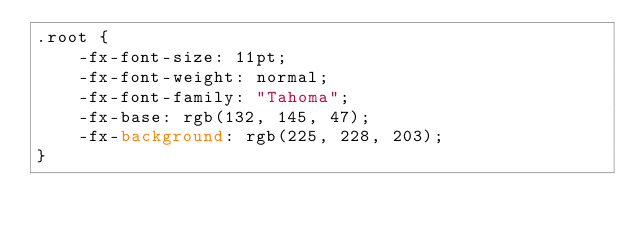Convert code to text. <code><loc_0><loc_0><loc_500><loc_500><_CSS_>.root {
	-fx-font-size: 11pt;
	-fx-font-weight: normal;
	-fx-font-family: "Tahoma";
	-fx-base: rgb(132, 145, 47);
	-fx-background: rgb(225, 228, 203);
}</code> 